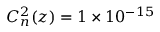<formula> <loc_0><loc_0><loc_500><loc_500>C _ { n } ^ { 2 } ( z ) = 1 \times 1 0 ^ { - 1 5 }</formula> 